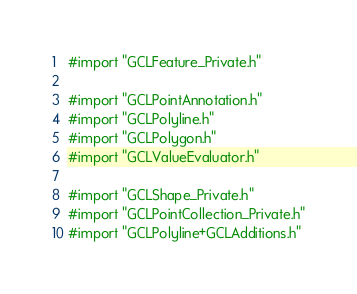Convert code to text. <code><loc_0><loc_0><loc_500><loc_500><_ObjectiveC_>#import "GCLFeature_Private.h"

#import "GCLPointAnnotation.h"
#import "GCLPolyline.h"
#import "GCLPolygon.h"
#import "GCLValueEvaluator.h"

#import "GCLShape_Private.h"
#import "GCLPointCollection_Private.h"
#import "GCLPolyline+GCLAdditions.h"</code> 